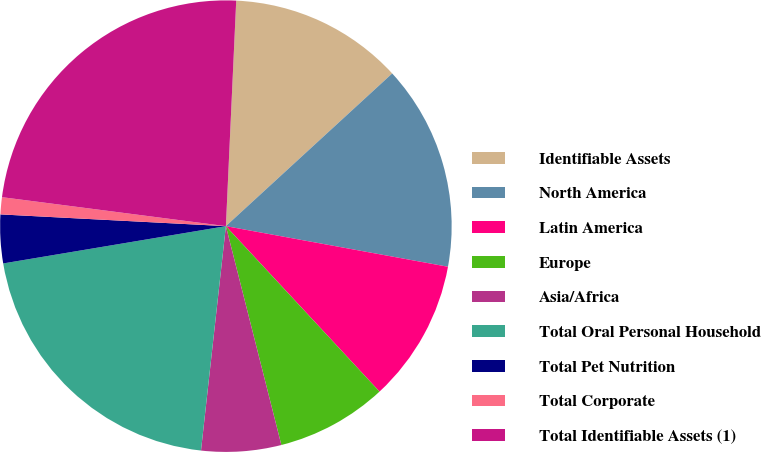Convert chart. <chart><loc_0><loc_0><loc_500><loc_500><pie_chart><fcel>Identifiable Assets<fcel>North America<fcel>Latin America<fcel>Europe<fcel>Asia/Africa<fcel>Total Oral Personal Household<fcel>Total Pet Nutrition<fcel>Total Corporate<fcel>Total Identifiable Assets (1)<nl><fcel>12.45%<fcel>14.7%<fcel>10.21%<fcel>7.96%<fcel>5.71%<fcel>20.6%<fcel>3.47%<fcel>1.22%<fcel>23.68%<nl></chart> 